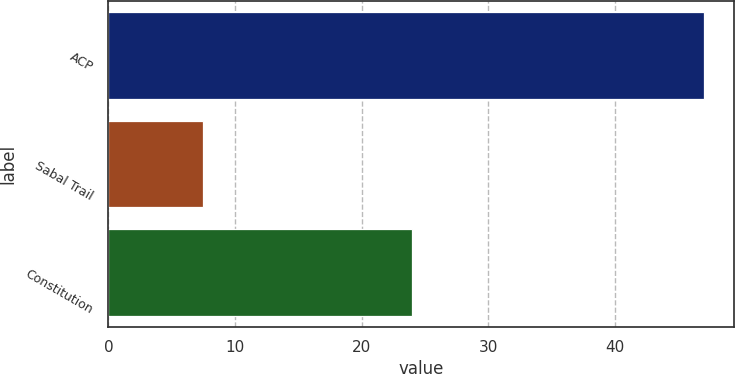Convert chart. <chart><loc_0><loc_0><loc_500><loc_500><bar_chart><fcel>ACP<fcel>Sabal Trail<fcel>Constitution<nl><fcel>47<fcel>7.5<fcel>24<nl></chart> 